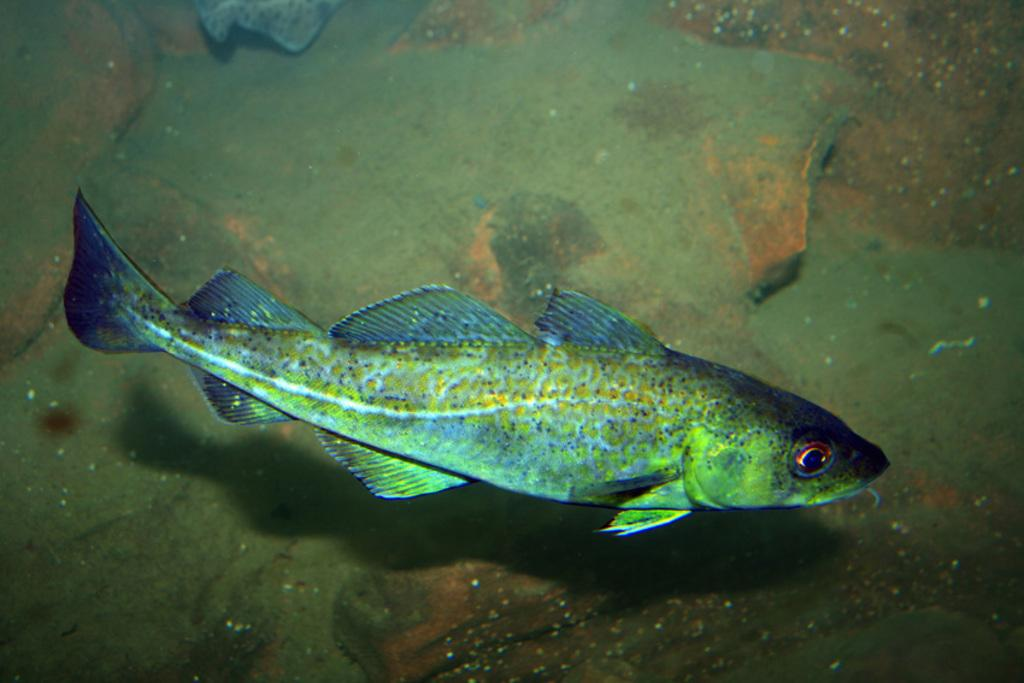What is in the water in the image? There is a fish in the water in the image. What else can be seen in the background of the image? There appears to be a rock in the background of the image. How many legs does the fish have in the image? Fish do not have legs; they have fins for swimming. 